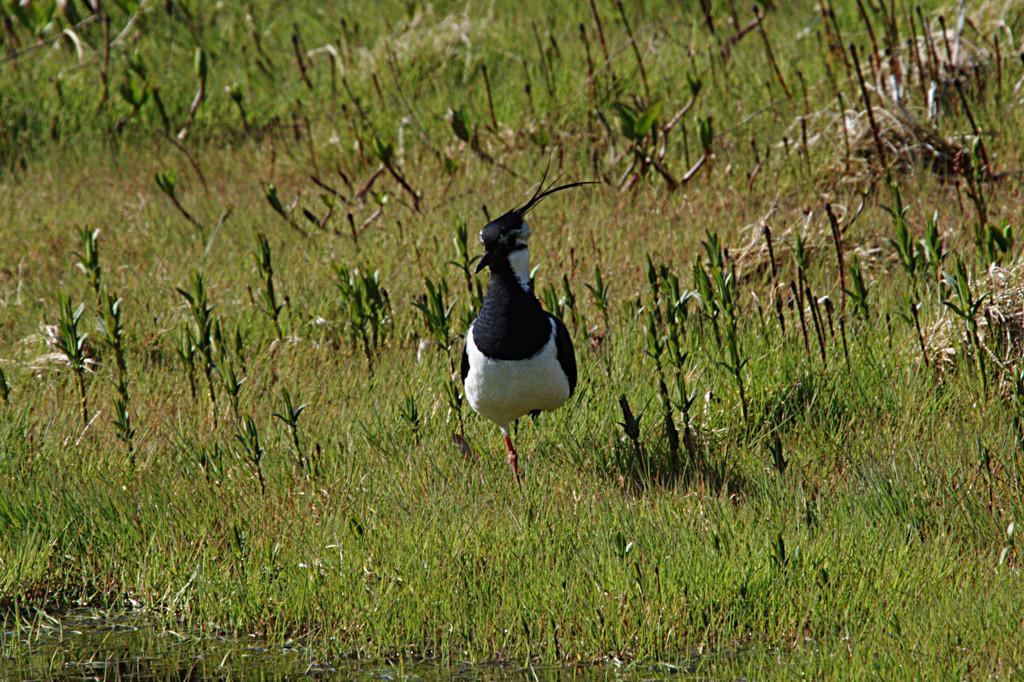In one or two sentences, can you explain what this image depicts? In this image I can see the bird which is in black and white color. It is on the grass. I can see the grass is in green color. 